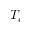<formula> <loc_0><loc_0><loc_500><loc_500>T _ { c }</formula> 